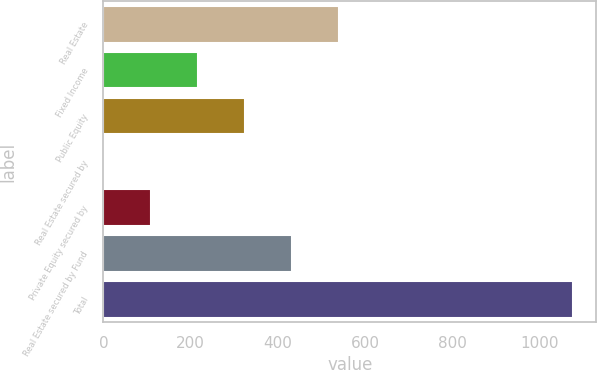Convert chart. <chart><loc_0><loc_0><loc_500><loc_500><bar_chart><fcel>Real Estate<fcel>Fixed Income<fcel>Public Equity<fcel>Real Estate secured by<fcel>Private Equity secured by<fcel>Real Estate secured by Fund<fcel>Total<nl><fcel>539<fcel>216.8<fcel>324.2<fcel>2<fcel>109.4<fcel>431.6<fcel>1076<nl></chart> 